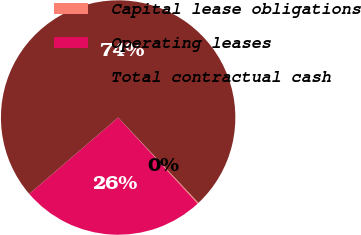Convert chart. <chart><loc_0><loc_0><loc_500><loc_500><pie_chart><fcel>Capital lease obligations<fcel>Operating leases<fcel>Total contractual cash<nl><fcel>0.16%<fcel>25.56%<fcel>74.28%<nl></chart> 